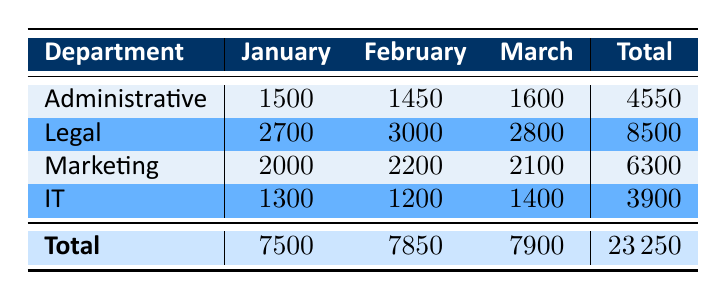What are the total expenses for the Administrative department? The table shows that the expenses for the Administrative department are 1500 in January, 1450 in February, and 1600 in March. To find the total, we add these values: 1500 + 1450 + 1600 = 4550.
Answer: 4550 Which department had the highest expenses in February? In February, the expenses for each department are: Administrative (1450), Legal (3000), Marketing (2200), and IT (1200). The highest value among these is 3000, which belongs to the Legal department.
Answer: Legal What was the average monthly expense for the Marketing department? The Marketing department had expenses of 2000 in January, 2200 in February, and 2100 in March. To find the average, we calculate the total expenses: 2000 + 2200 + 2100 = 6300 and then divide by the number of months (3): 6300 / 3 = 2100.
Answer: 2100 True or False: The total expenses for all departments in March exceeded 8000. The total expenses for March are: 1600 (Administrative) + 2800 (Legal) + 2100 (Marketing) + 1400 (IT) = 7900. Since 7900 is less than 8000, the statement is false.
Answer: False Which department shows the least total expenses over the three months? We calculate the total expenses for each department: Administrative = 4550, Legal = 8500, Marketing = 6300, IT = 3900. The department with the least total is IT, with 3900.
Answer: IT What are the total expenses for the IT department over the three months? The IT department's expenses are 1300 in January, 1200 in February, and 1400 in March. Adding these together gives: 1300 + 1200 + 1400 = 3900.
Answer: 3900 Which department has the highest total expenses across all months? The total expenses for each department are: Administrative (4550), Legal (8500), Marketing (6300), and IT (3900). The highest total is 8500 from the Legal department.
Answer: Legal What is the difference between the total expenses of the Legal department and the total expenses of the IT department? The total expenses for Legal are 8500, and for IT they are 3900. The difference is calculated as: 8500 - 3900 = 4600.
Answer: 4600 